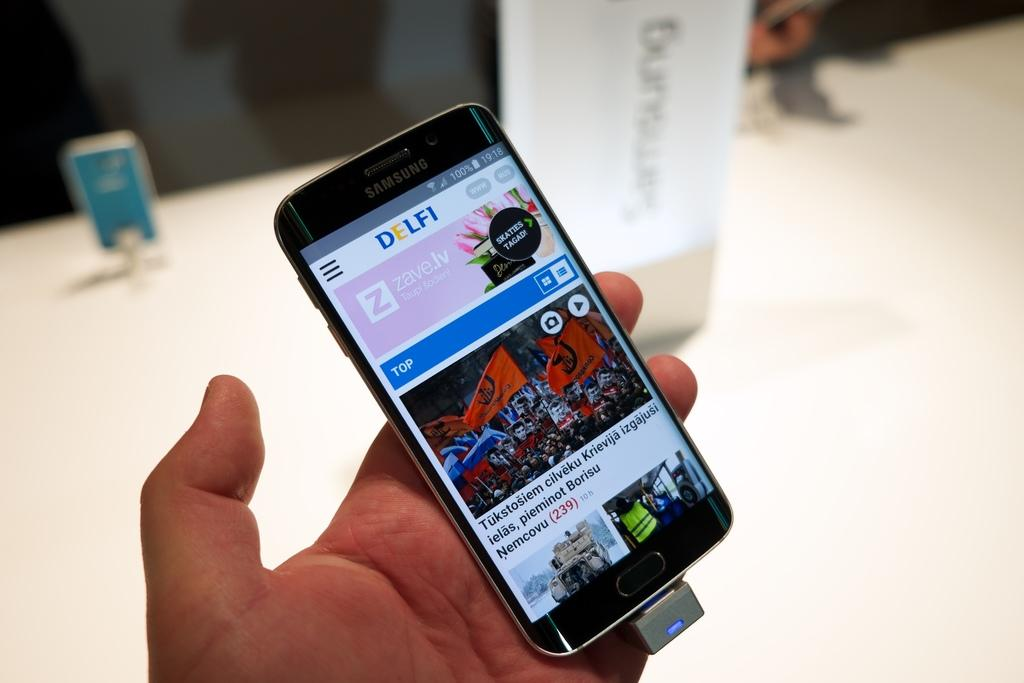What is the person holding in the image? The person is holding a mobile in the image. What can be seen on the mobile? The mobile has a screen that displays images. Can you describe the background of the image? The background of the image is blurred. What type of acoustics can be heard coming from the goose in the image? There is no goose present in the image, so it's not possible to determine what, if any, acoustics might be heard. 